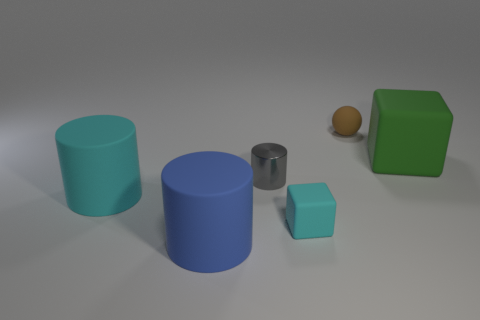Which objects seem out of place or different? The small silver cylinder and the very small orange sphere appear distinct. The silver cylinder's reflective surface stands out among the matte finishes of the other objects, and the orange sphere's color and shape contrast with the predominantly cylindrical and cubic forms seen in the scene. 